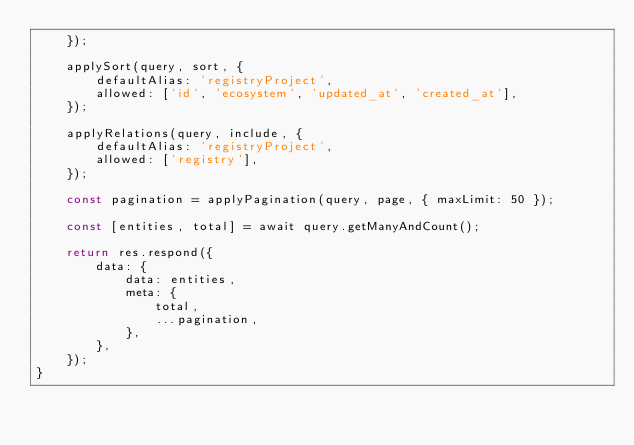<code> <loc_0><loc_0><loc_500><loc_500><_TypeScript_>    });

    applySort(query, sort, {
        defaultAlias: 'registryProject',
        allowed: ['id', 'ecosystem', 'updated_at', 'created_at'],
    });

    applyRelations(query, include, {
        defaultAlias: 'registryProject',
        allowed: ['registry'],
    });

    const pagination = applyPagination(query, page, { maxLimit: 50 });

    const [entities, total] = await query.getManyAndCount();

    return res.respond({
        data: {
            data: entities,
            meta: {
                total,
                ...pagination,
            },
        },
    });
}
</code> 